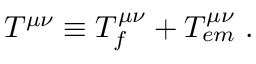Convert formula to latex. <formula><loc_0><loc_0><loc_500><loc_500>T ^ { \mu \nu } \equiv T _ { f } ^ { \mu \nu } + T _ { e m } ^ { \mu \nu } \, .</formula> 